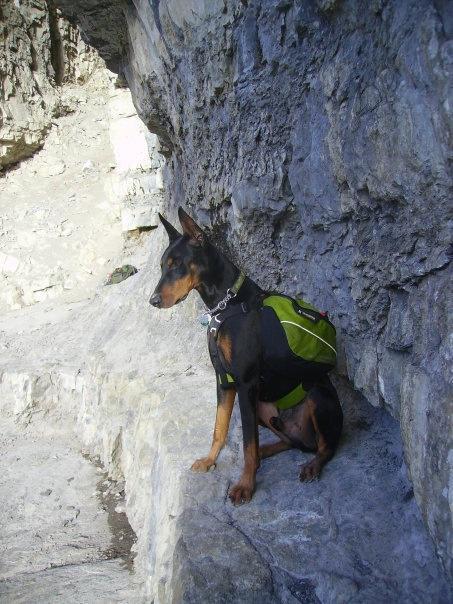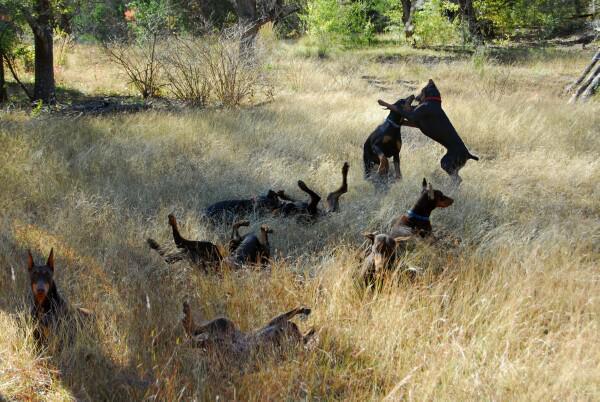The first image is the image on the left, the second image is the image on the right. For the images shown, is this caption "There is at least one human to the left of the dog." true? Answer yes or no. No. The first image is the image on the left, the second image is the image on the right. Examine the images to the left and right. Is the description "A dog is laying on a blanket." accurate? Answer yes or no. No. 